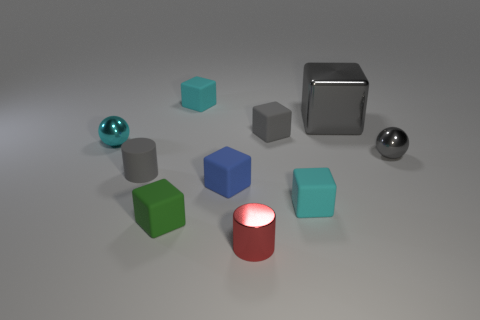Subtract all blue cubes. How many cubes are left? 5 Subtract all tiny blue cubes. How many cubes are left? 5 Subtract all green cubes. Subtract all blue cylinders. How many cubes are left? 5 Subtract all blocks. How many objects are left? 4 Add 9 cyan balls. How many cyan balls are left? 10 Add 1 small shiny blocks. How many small shiny blocks exist? 1 Subtract 1 green cubes. How many objects are left? 9 Subtract all gray metallic blocks. Subtract all red cylinders. How many objects are left? 8 